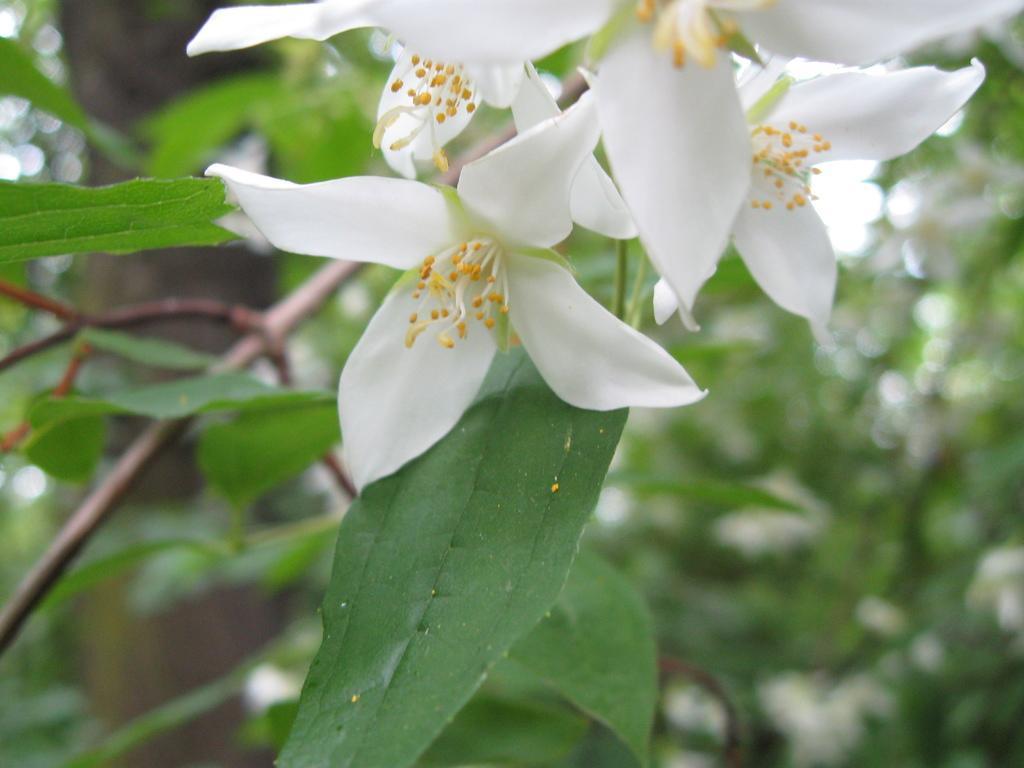How would you summarize this image in a sentence or two? In this picture I can see white flowers and leaves, and there is blur background. 